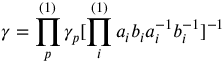Convert formula to latex. <formula><loc_0><loc_0><loc_500><loc_500>\gamma = \prod _ { p } ^ { ( 1 ) } \gamma _ { p } [ \prod _ { i } ^ { ( 1 ) } a _ { i } b _ { i } a _ { i } ^ { - 1 } b _ { i } ^ { - 1 } ] ^ { - 1 }</formula> 